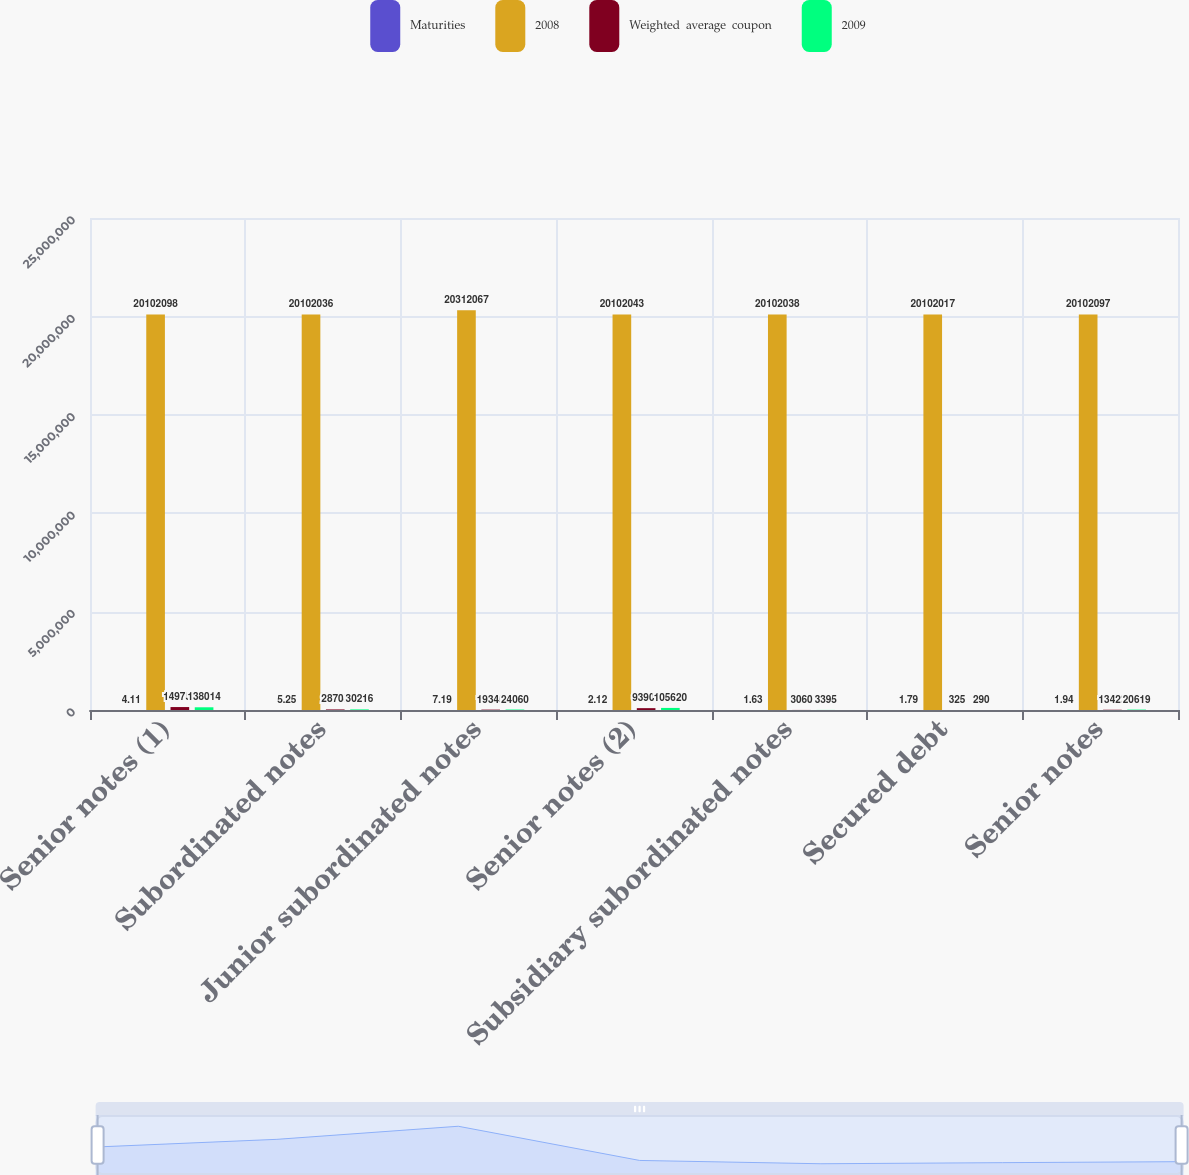Convert chart. <chart><loc_0><loc_0><loc_500><loc_500><stacked_bar_chart><ecel><fcel>Senior notes (1)<fcel>Subordinated notes<fcel>Junior subordinated notes<fcel>Senior notes (2)<fcel>Subsidiary subordinated notes<fcel>Secured debt<fcel>Senior notes<nl><fcel>Maturities<fcel>4.11<fcel>5.25<fcel>7.19<fcel>2.12<fcel>1.63<fcel>1.79<fcel>1.94<nl><fcel>2008<fcel>2.01021e+07<fcel>2.0102e+07<fcel>2.03121e+07<fcel>2.0102e+07<fcel>2.0102e+07<fcel>2.0102e+07<fcel>2.01021e+07<nl><fcel>Weighted  average  coupon<fcel>149751<fcel>28708<fcel>19345<fcel>93909<fcel>3060<fcel>325<fcel>13422<nl><fcel>2009<fcel>138014<fcel>30216<fcel>24060<fcel>105620<fcel>3395<fcel>290<fcel>20619<nl></chart> 